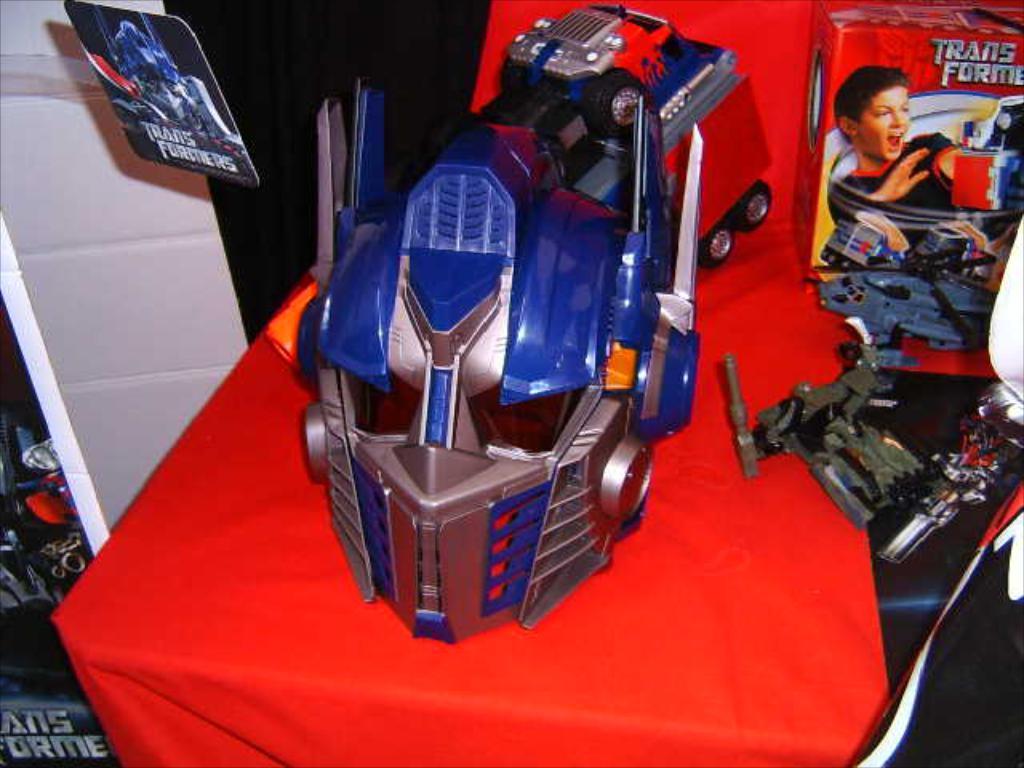What brand is the mask from in the middle?
Offer a terse response. Transformers. 